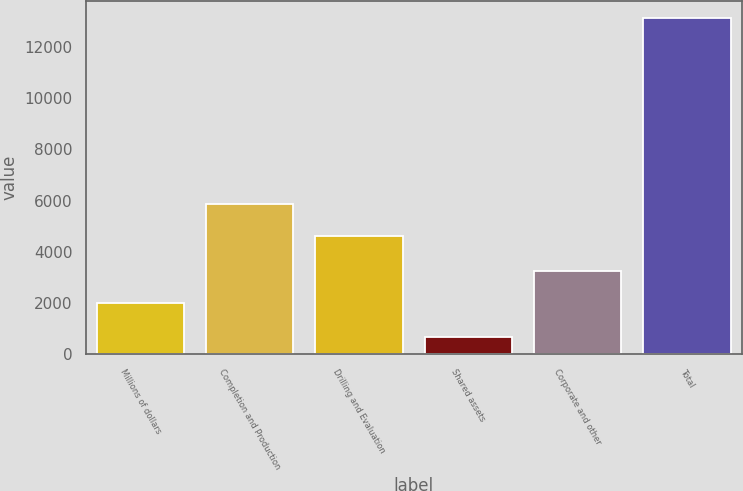Convert chart. <chart><loc_0><loc_0><loc_500><loc_500><bar_chart><fcel>Millions of dollars<fcel>Completion and Production<fcel>Drilling and Evaluation<fcel>Shared assets<fcel>Corporate and other<fcel>Total<nl><fcel>2007<fcel>5852.3<fcel>4606<fcel>672<fcel>3253.3<fcel>13135<nl></chart> 